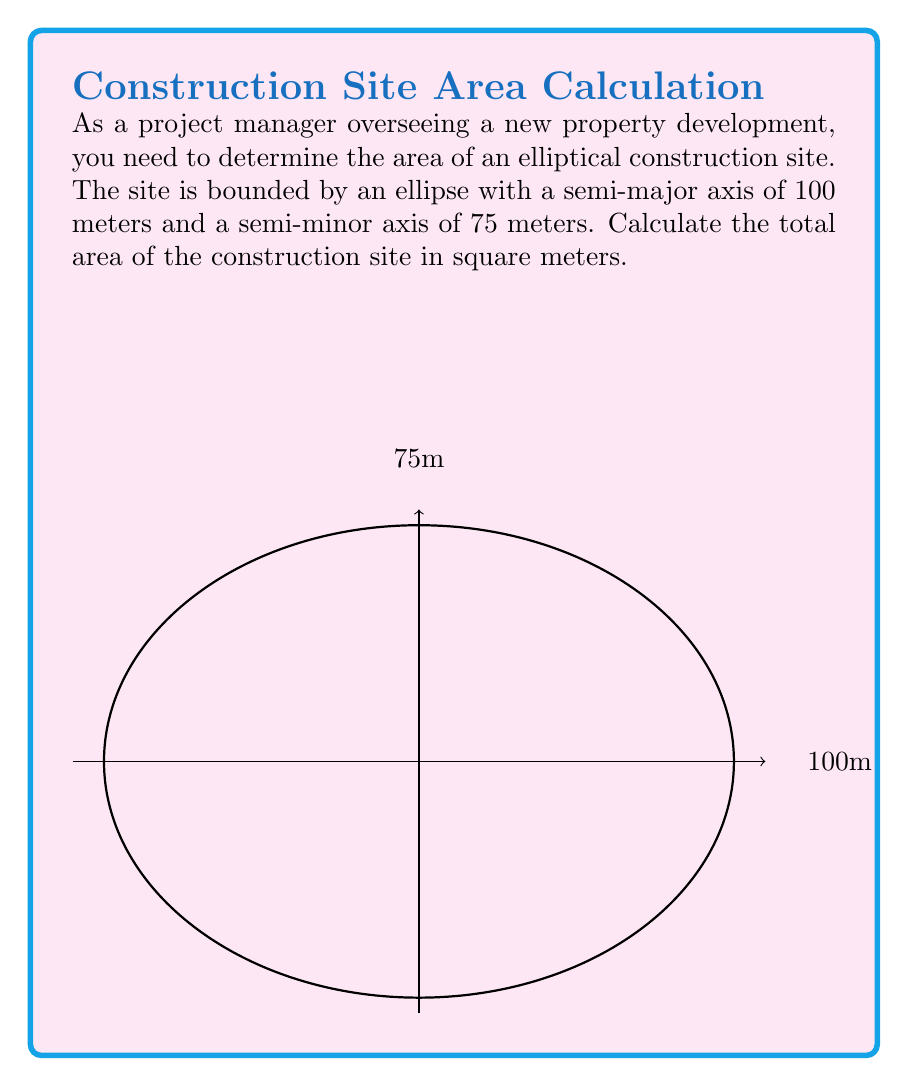Can you solve this math problem? To solve this problem, we'll use the formula for the area of an ellipse:

$$A = \pi ab$$

Where:
$A$ = area of the ellipse
$a$ = length of the semi-major axis
$b$ = length of the semi-minor axis

Given:
$a = 100$ meters
$b = 75$ meters

Step 1: Substitute the values into the formula:
$$A = \pi(100)(75)$$

Step 2: Multiply the values inside the parentheses:
$$A = \pi(7500)$$

Step 3: Multiply by $\pi$:
$$A = 7500\pi$$

Step 4: Calculate the final value (rounded to the nearest whole number):
$$A \approx 23,562 \text{ m}^2$$

Therefore, the total area of the elliptical construction site is approximately 23,562 square meters.
Answer: 23,562 m² 